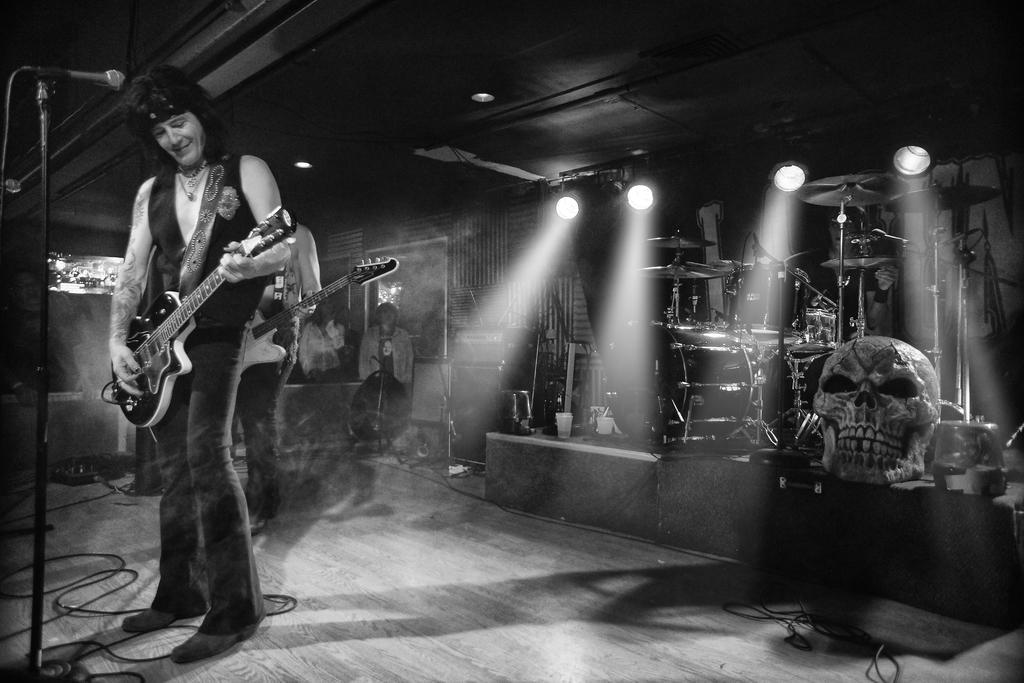Could you give a brief overview of what you see in this image? On the left side we can see one man holding guitar. In front of him we can see microphone. Coming to the background we can see the lights and few musical instruments and some persons were standing. 